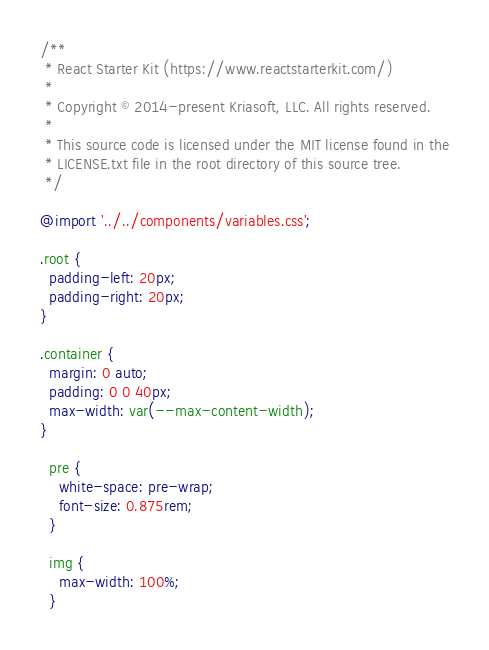Convert code to text. <code><loc_0><loc_0><loc_500><loc_500><_CSS_>/**
 * React Starter Kit (https://www.reactstarterkit.com/)
 *
 * Copyright © 2014-present Kriasoft, LLC. All rights reserved.
 *
 * This source code is licensed under the MIT license found in the
 * LICENSE.txt file in the root directory of this source tree.
 */

@import '../../components/variables.css';

.root {
  padding-left: 20px;
  padding-right: 20px;
}

.container {
  margin: 0 auto;
  padding: 0 0 40px;
  max-width: var(--max-content-width);
}

  pre {
    white-space: pre-wrap;
    font-size: 0.875rem;
  }

  img {
    max-width: 100%;
  }
</code> 